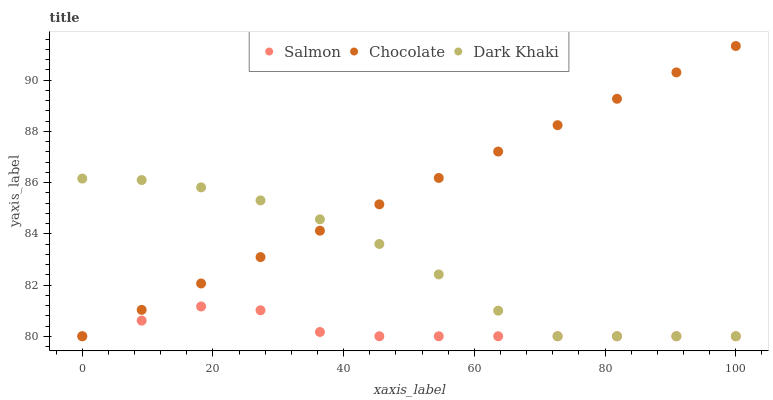Does Salmon have the minimum area under the curve?
Answer yes or no. Yes. Does Chocolate have the maximum area under the curve?
Answer yes or no. Yes. Does Chocolate have the minimum area under the curve?
Answer yes or no. No. Does Salmon have the maximum area under the curve?
Answer yes or no. No. Is Chocolate the smoothest?
Answer yes or no. Yes. Is Dark Khaki the roughest?
Answer yes or no. Yes. Is Salmon the smoothest?
Answer yes or no. No. Is Salmon the roughest?
Answer yes or no. No. Does Dark Khaki have the lowest value?
Answer yes or no. Yes. Does Chocolate have the highest value?
Answer yes or no. Yes. Does Salmon have the highest value?
Answer yes or no. No. Does Dark Khaki intersect Salmon?
Answer yes or no. Yes. Is Dark Khaki less than Salmon?
Answer yes or no. No. Is Dark Khaki greater than Salmon?
Answer yes or no. No. 